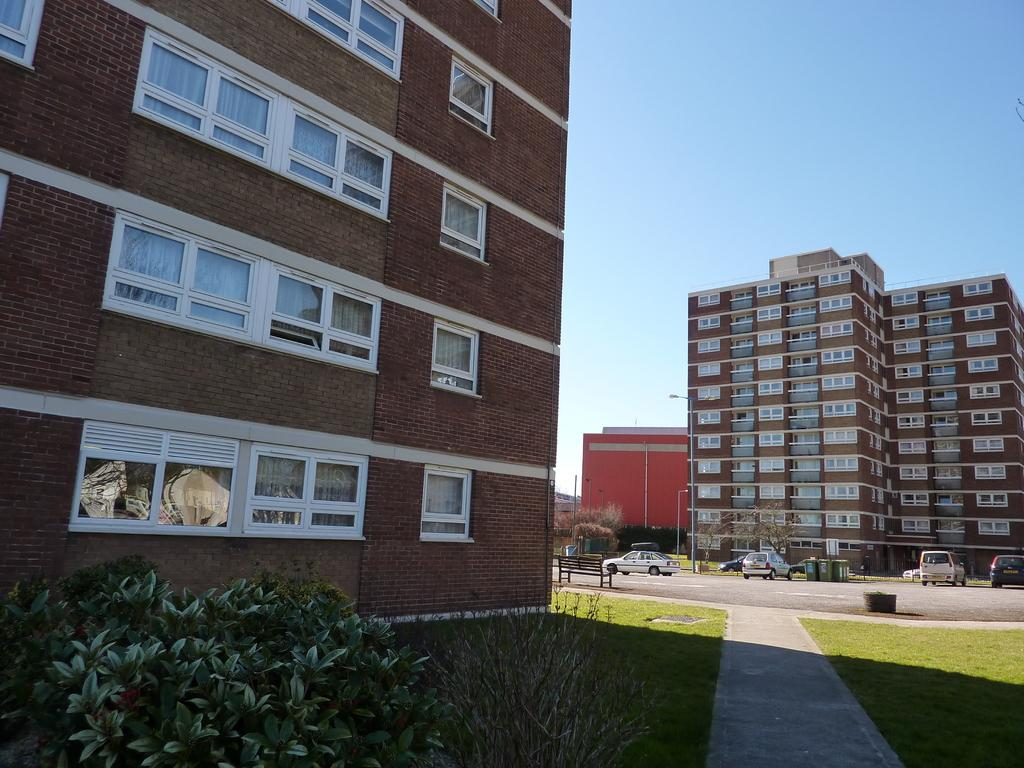What type of vegetation can be seen in the image? There are plants and grass in the image. What type of structure is present in the image? There is a building in the image. What can be seen through the windows in the image? The windows in the image provide a view of the background, which includes buildings, a bench, vehicles, a pole, and the sky. What type of button is being pushed by the plants in the image? There are no buttons present in the image, and the plants are not performing any actions. What type of badge is being worn by the vehicles in the background? There are no badges visible on the vehicles in the background; they are simply parked in the image. 